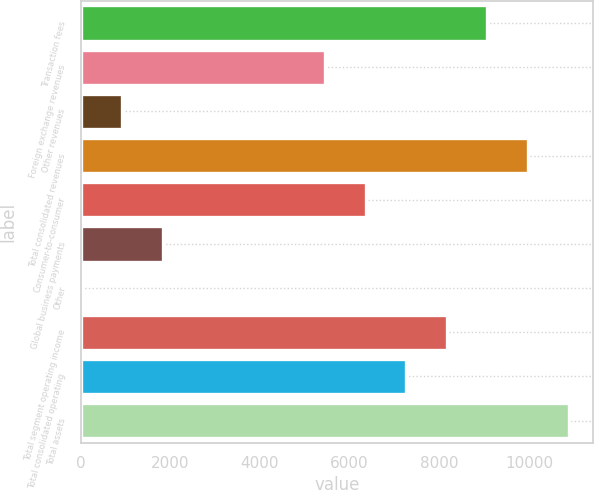<chart> <loc_0><loc_0><loc_500><loc_500><bar_chart><fcel>Transaction fees<fcel>Foreign exchange revenues<fcel>Other revenues<fcel>Total consolidated revenues<fcel>Consumer-to-consumer<fcel>Global business payments<fcel>Other<fcel>Total segment operating income<fcel>Total consolidated operating<fcel>Total assets<nl><fcel>9069.9<fcel>5451.78<fcel>929.13<fcel>9974.43<fcel>6356.31<fcel>1833.66<fcel>24.6<fcel>8165.37<fcel>7260.84<fcel>10879<nl></chart> 